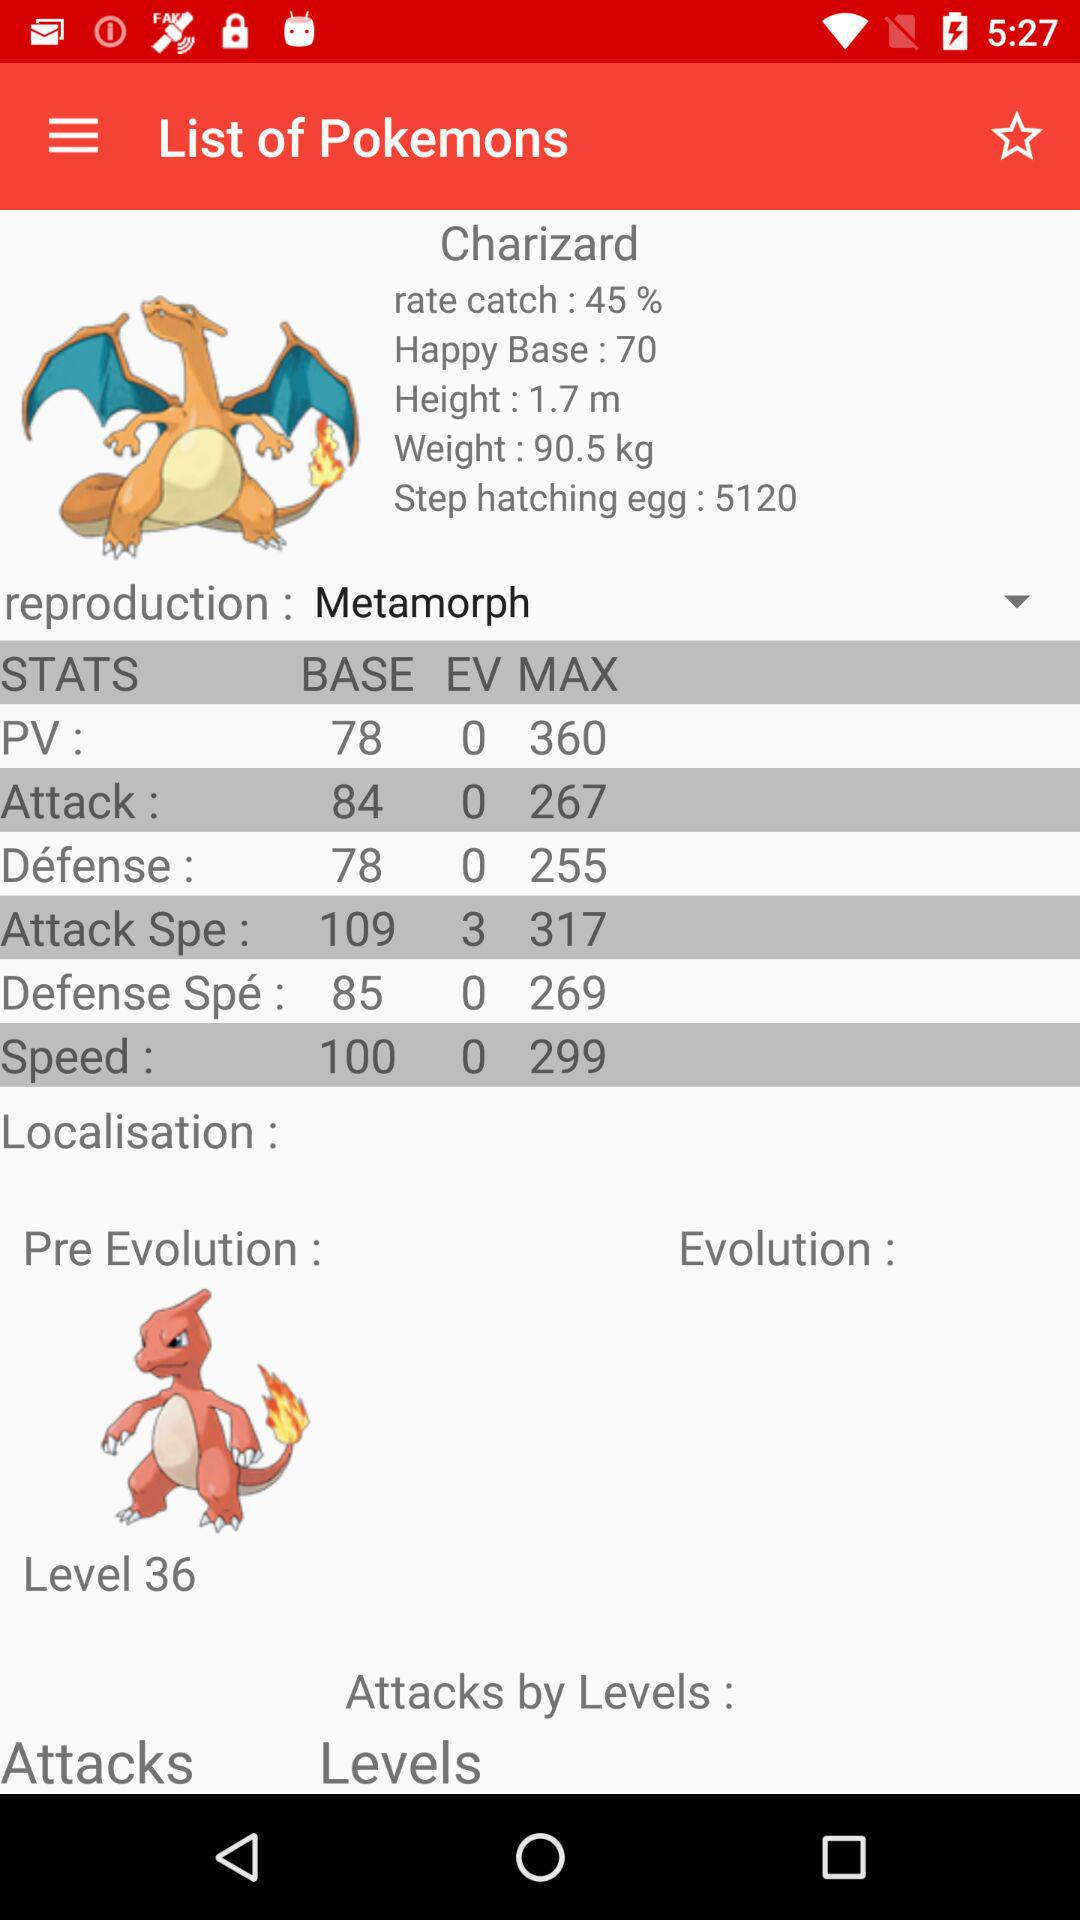What is the percentage of the rate catch? The percentage of the rate catch is 45. 